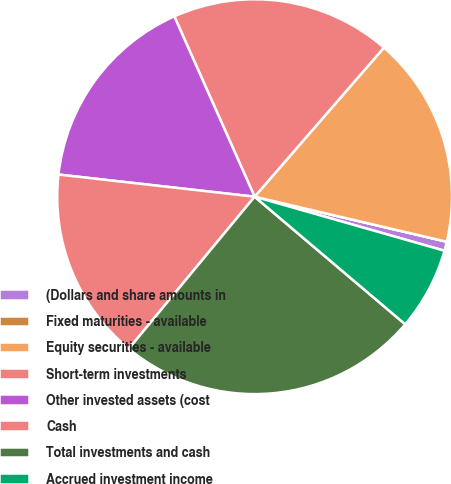<chart> <loc_0><loc_0><loc_500><loc_500><pie_chart><fcel>(Dollars and share amounts in<fcel>Fixed maturities - available<fcel>Equity securities - available<fcel>Short-term investments<fcel>Other invested assets (cost<fcel>Cash<fcel>Total investments and cash<fcel>Accrued investment income<nl><fcel>0.75%<fcel>0.0%<fcel>17.29%<fcel>18.04%<fcel>16.54%<fcel>15.79%<fcel>24.81%<fcel>6.77%<nl></chart> 